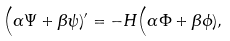<formula> <loc_0><loc_0><loc_500><loc_500>& \Big ( \alpha \Psi + \beta \psi ) ^ { \prime } = - H \Big ( \alpha \Phi + \beta \phi ) ,</formula> 